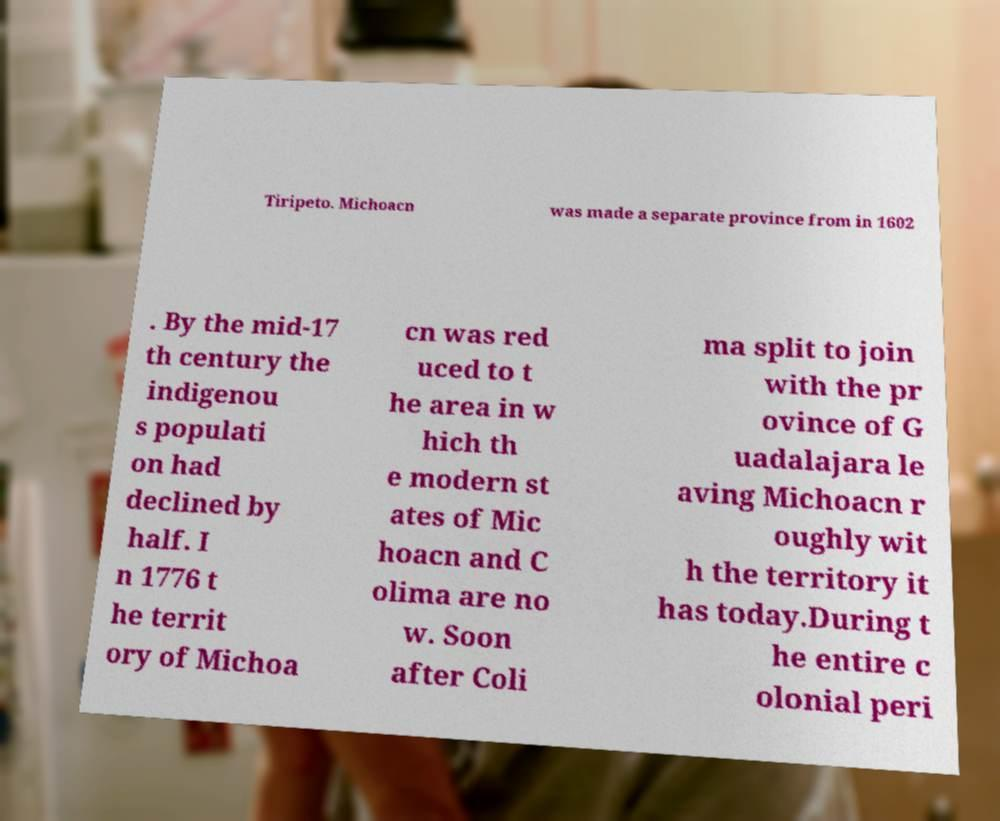Can you read and provide the text displayed in the image?This photo seems to have some interesting text. Can you extract and type it out for me? Tiripeto. Michoacn was made a separate province from in 1602 . By the mid-17 th century the indigenou s populati on had declined by half. I n 1776 t he territ ory of Michoa cn was red uced to t he area in w hich th e modern st ates of Mic hoacn and C olima are no w. Soon after Coli ma split to join with the pr ovince of G uadalajara le aving Michoacn r oughly wit h the territory it has today.During t he entire c olonial peri 